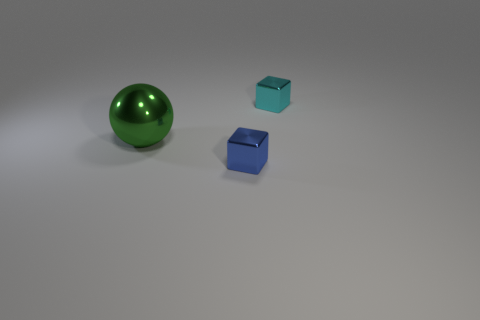Add 2 small gray metallic cylinders. How many objects exist? 5 Subtract 0 cyan cylinders. How many objects are left? 3 Subtract all cubes. How many objects are left? 1 Subtract all tiny blue metallic cubes. Subtract all red cubes. How many objects are left? 2 Add 3 cyan metallic objects. How many cyan metallic objects are left? 4 Add 2 big metallic balls. How many big metallic balls exist? 3 